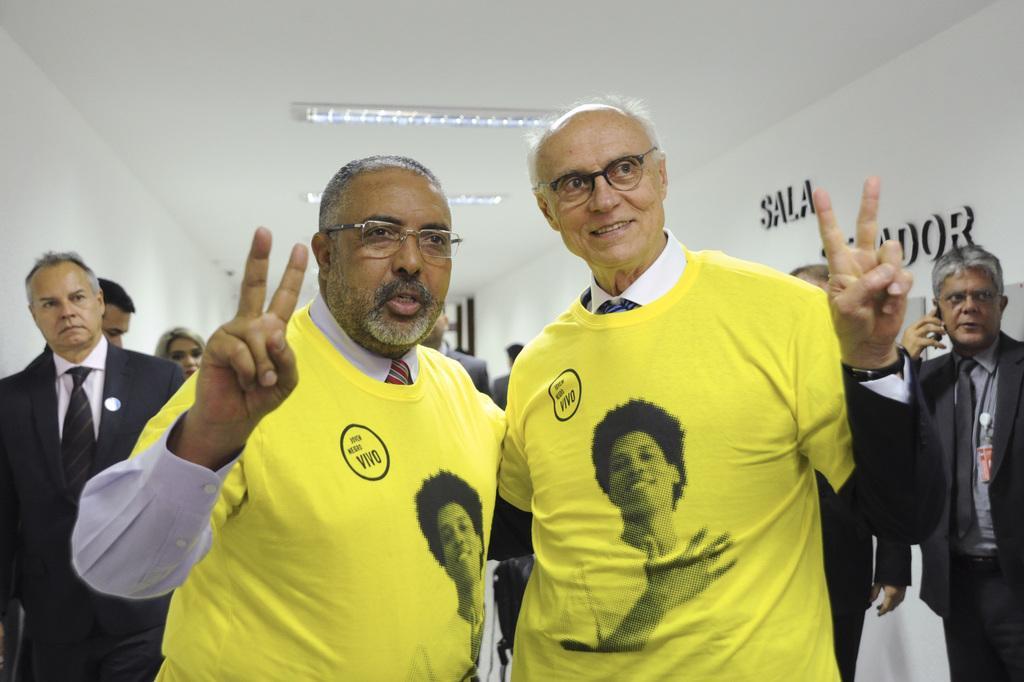Describe this image in one or two sentences. Here we can see two persons are posing to a camera and they have spectacles. In the background we can see few persons, lights, and wall. 